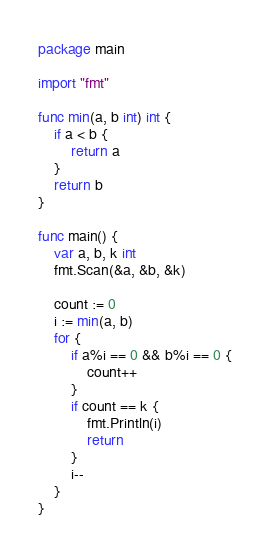Convert code to text. <code><loc_0><loc_0><loc_500><loc_500><_Go_>package main

import "fmt"

func min(a, b int) int {
	if a < b {
		return a
	}
	return b
}

func main() {
	var a, b, k int
	fmt.Scan(&a, &b, &k)

	count := 0
	i := min(a, b)
	for {
		if a%i == 0 && b%i == 0 {
			count++
		}
		if count == k {
			fmt.Println(i)
			return
		}
		i--
	}
}
</code> 